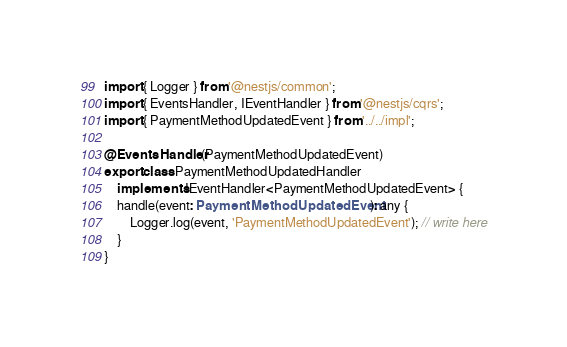Convert code to text. <code><loc_0><loc_0><loc_500><loc_500><_TypeScript_>import { Logger } from '@nestjs/common';
import { EventsHandler, IEventHandler } from '@nestjs/cqrs';
import { PaymentMethodUpdatedEvent } from '../../impl';

@EventsHandler(PaymentMethodUpdatedEvent)
export class PaymentMethodUpdatedHandler
    implements IEventHandler<PaymentMethodUpdatedEvent> {
    handle(event: PaymentMethodUpdatedEvent): any {
        Logger.log(event, 'PaymentMethodUpdatedEvent'); // write here
    }
}
</code> 